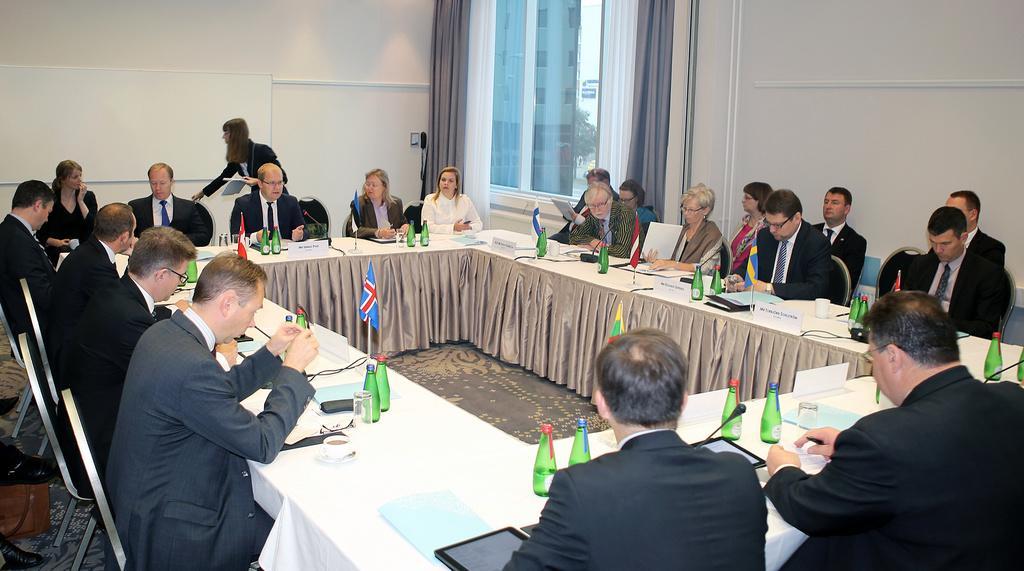How would you summarize this image in a sentence or two? Here in the image we can see the group of people were sitting around the table. And in the center there is a flag. And on table there is a cloth and water bottles,tab,coffee cup, glasses etc. Coming to the background there is a curtain in brown color. 